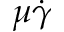<formula> <loc_0><loc_0><loc_500><loc_500>\mu \dot { \gamma }</formula> 